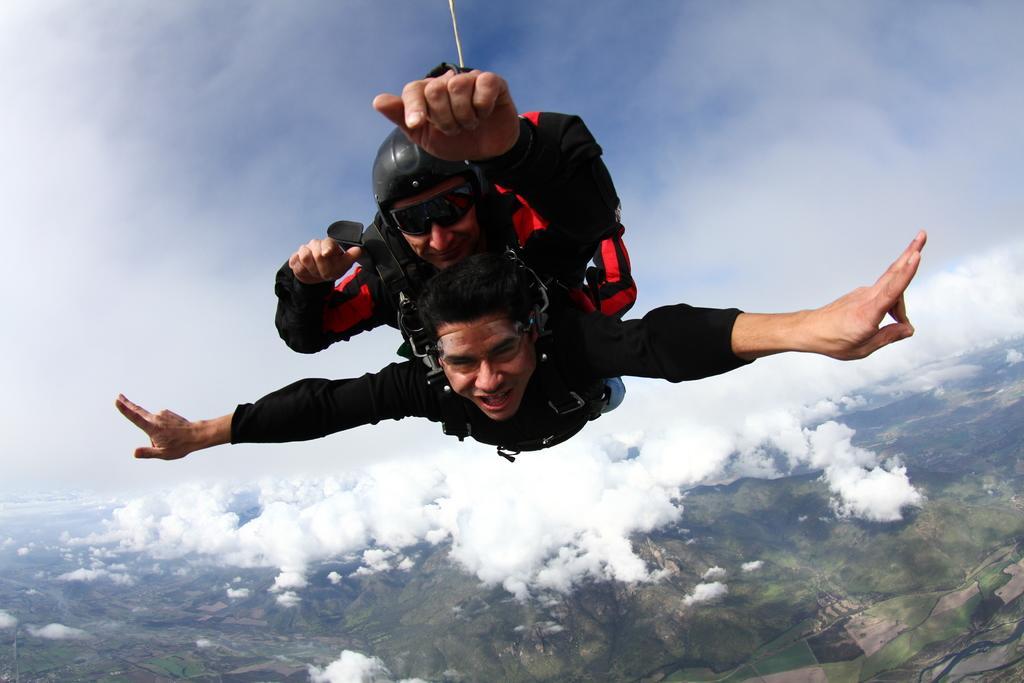In one or two sentences, can you explain what this image depicts? In this picture there are two persons flying in the sky. At the bottom there are mountains. At the top there is sky and there are clouds. 